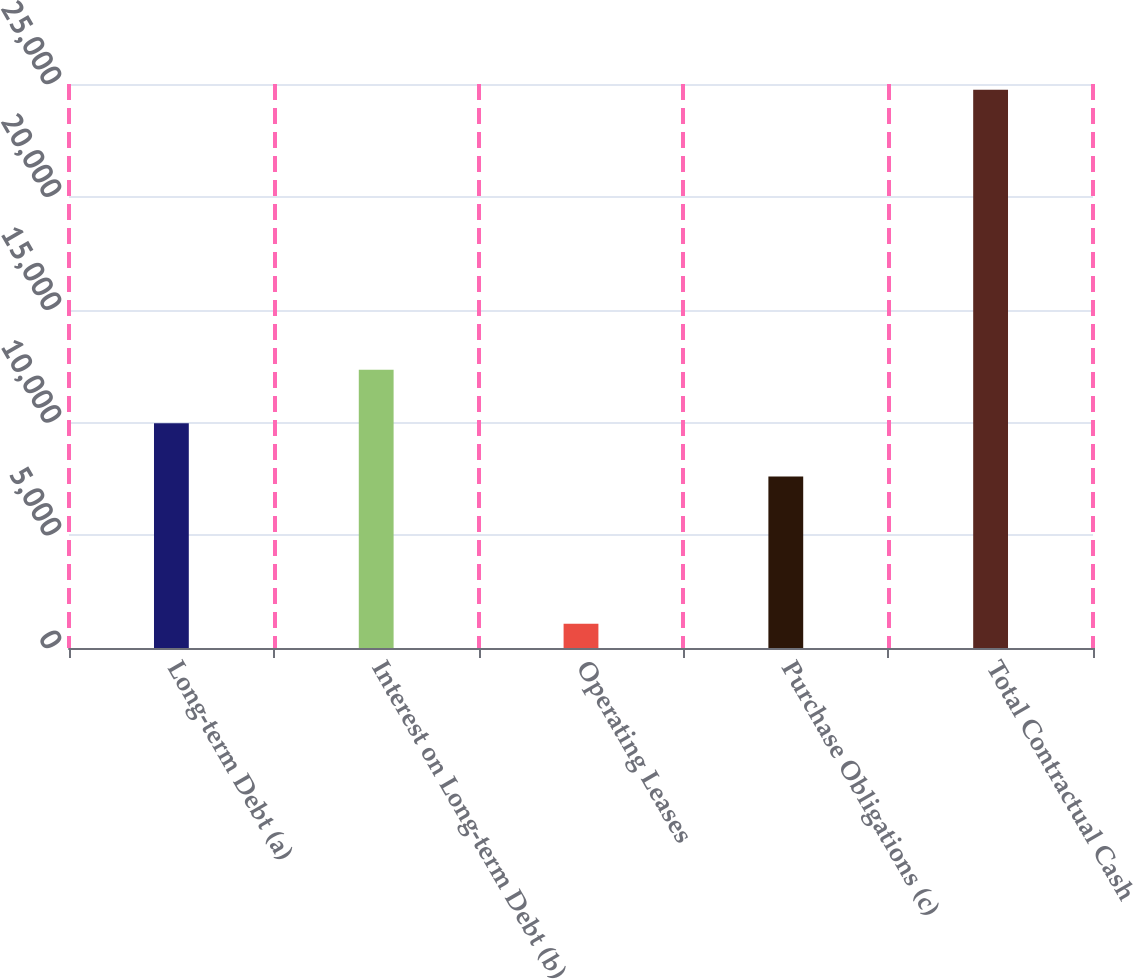<chart> <loc_0><loc_0><loc_500><loc_500><bar_chart><fcel>Long-term Debt (a)<fcel>Interest on Long-term Debt (b)<fcel>Operating Leases<fcel>Purchase Obligations (c)<fcel>Total Contractual Cash<nl><fcel>9965.4<fcel>12331.8<fcel>1080<fcel>7599<fcel>24744<nl></chart> 